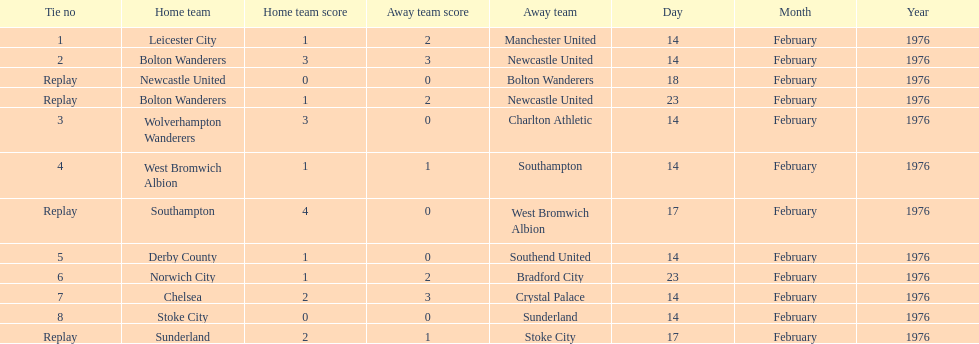How many of these games occurred before 17 february 1976? 7. 